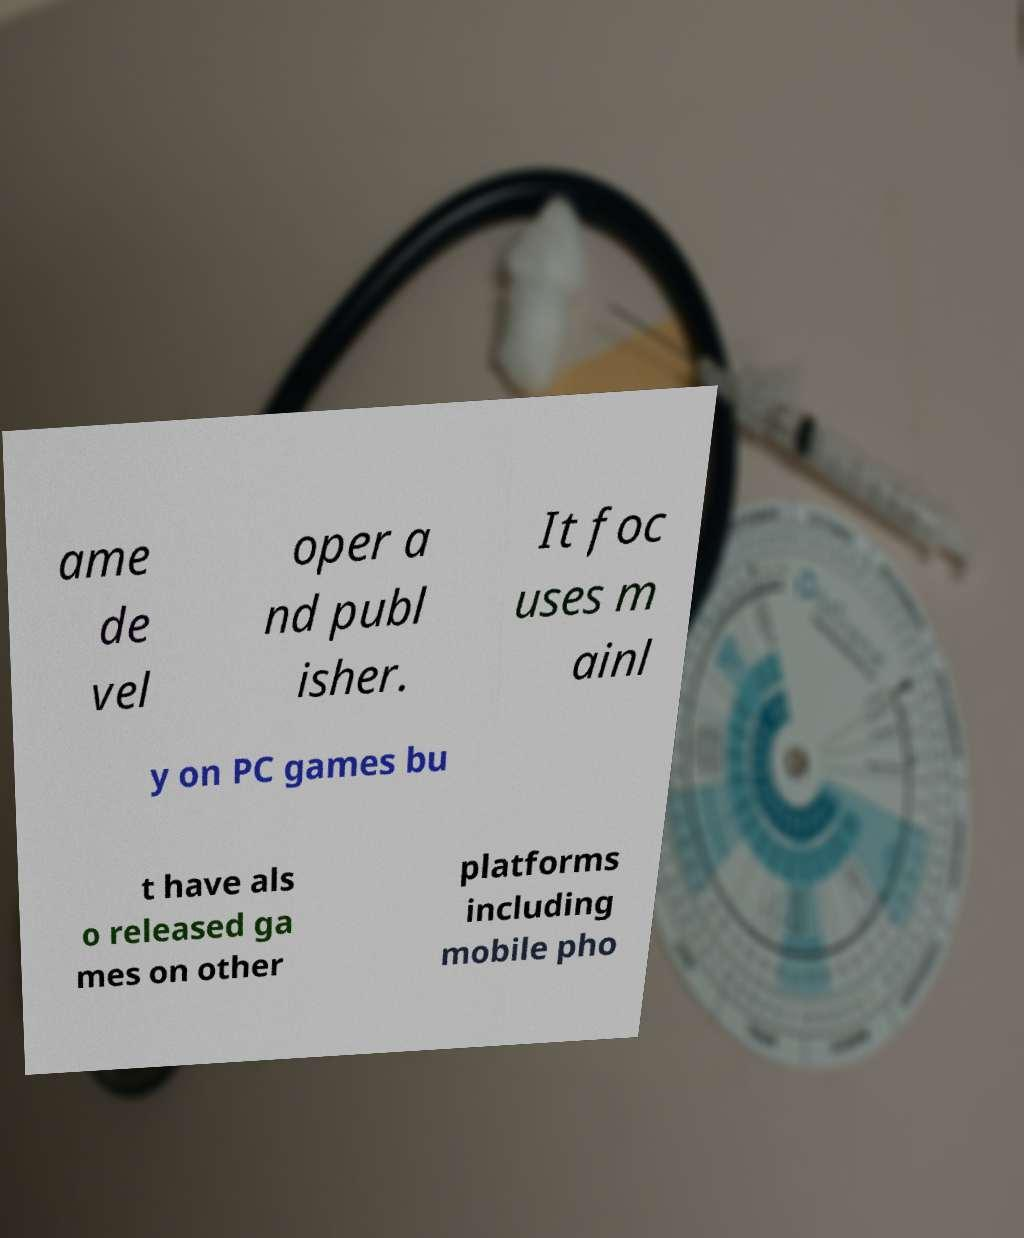I need the written content from this picture converted into text. Can you do that? ame de vel oper a nd publ isher. It foc uses m ainl y on PC games bu t have als o released ga mes on other platforms including mobile pho 